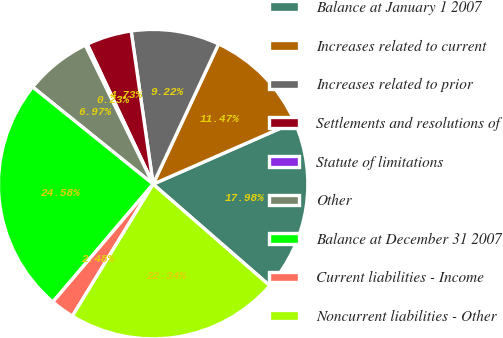<chart> <loc_0><loc_0><loc_500><loc_500><pie_chart><fcel>Balance at January 1 2007<fcel>Increases related to current<fcel>Increases related to prior<fcel>Settlements and resolutions of<fcel>Statute of limitations<fcel>Other<fcel>Balance at December 31 2007<fcel>Current liabilities - Income<fcel>Noncurrent liabilities - Other<nl><fcel>17.98%<fcel>11.47%<fcel>9.22%<fcel>4.73%<fcel>0.23%<fcel>6.97%<fcel>24.58%<fcel>2.48%<fcel>22.34%<nl></chart> 